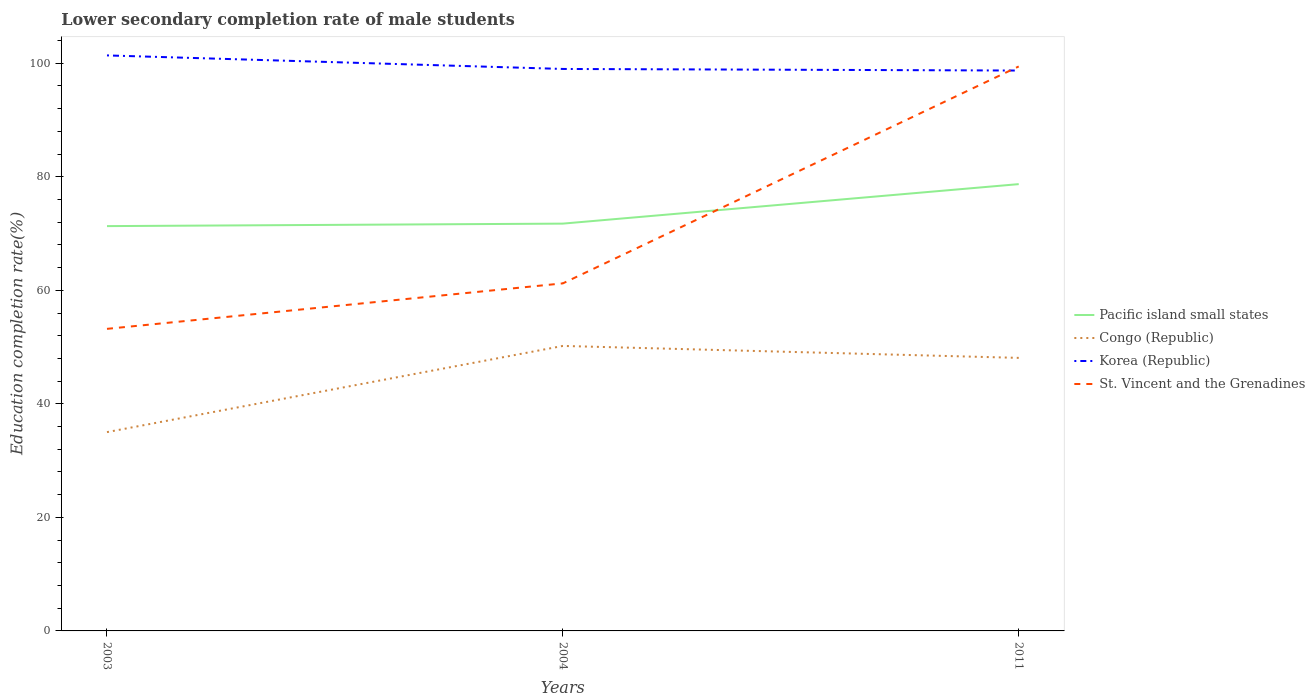How many different coloured lines are there?
Your answer should be very brief. 4. Is the number of lines equal to the number of legend labels?
Your response must be concise. Yes. Across all years, what is the maximum lower secondary completion rate of male students in Korea (Republic)?
Offer a very short reply. 98.72. What is the total lower secondary completion rate of male students in Pacific island small states in the graph?
Your response must be concise. -0.44. What is the difference between the highest and the second highest lower secondary completion rate of male students in Congo (Republic)?
Offer a very short reply. 15.18. Is the lower secondary completion rate of male students in Pacific island small states strictly greater than the lower secondary completion rate of male students in Korea (Republic) over the years?
Give a very brief answer. Yes. How many lines are there?
Offer a terse response. 4. Does the graph contain any zero values?
Keep it short and to the point. No. Does the graph contain grids?
Keep it short and to the point. No. How are the legend labels stacked?
Ensure brevity in your answer.  Vertical. What is the title of the graph?
Give a very brief answer. Lower secondary completion rate of male students. What is the label or title of the X-axis?
Keep it short and to the point. Years. What is the label or title of the Y-axis?
Give a very brief answer. Education completion rate(%). What is the Education completion rate(%) in Pacific island small states in 2003?
Offer a terse response. 71.31. What is the Education completion rate(%) of Congo (Republic) in 2003?
Give a very brief answer. 35.02. What is the Education completion rate(%) of Korea (Republic) in 2003?
Your answer should be compact. 101.38. What is the Education completion rate(%) in St. Vincent and the Grenadines in 2003?
Your answer should be compact. 53.21. What is the Education completion rate(%) in Pacific island small states in 2004?
Your answer should be very brief. 71.75. What is the Education completion rate(%) in Congo (Republic) in 2004?
Make the answer very short. 50.21. What is the Education completion rate(%) in Korea (Republic) in 2004?
Provide a succinct answer. 99. What is the Education completion rate(%) of St. Vincent and the Grenadines in 2004?
Offer a very short reply. 61.23. What is the Education completion rate(%) of Pacific island small states in 2011?
Provide a short and direct response. 78.71. What is the Education completion rate(%) of Congo (Republic) in 2011?
Your answer should be compact. 48.1. What is the Education completion rate(%) of Korea (Republic) in 2011?
Ensure brevity in your answer.  98.72. What is the Education completion rate(%) in St. Vincent and the Grenadines in 2011?
Provide a short and direct response. 99.44. Across all years, what is the maximum Education completion rate(%) of Pacific island small states?
Make the answer very short. 78.71. Across all years, what is the maximum Education completion rate(%) of Congo (Republic)?
Your answer should be very brief. 50.21. Across all years, what is the maximum Education completion rate(%) of Korea (Republic)?
Make the answer very short. 101.38. Across all years, what is the maximum Education completion rate(%) of St. Vincent and the Grenadines?
Provide a succinct answer. 99.44. Across all years, what is the minimum Education completion rate(%) of Pacific island small states?
Ensure brevity in your answer.  71.31. Across all years, what is the minimum Education completion rate(%) in Congo (Republic)?
Your response must be concise. 35.02. Across all years, what is the minimum Education completion rate(%) of Korea (Republic)?
Your answer should be very brief. 98.72. Across all years, what is the minimum Education completion rate(%) in St. Vincent and the Grenadines?
Offer a very short reply. 53.21. What is the total Education completion rate(%) in Pacific island small states in the graph?
Keep it short and to the point. 221.77. What is the total Education completion rate(%) in Congo (Republic) in the graph?
Offer a terse response. 133.33. What is the total Education completion rate(%) of Korea (Republic) in the graph?
Keep it short and to the point. 299.1. What is the total Education completion rate(%) of St. Vincent and the Grenadines in the graph?
Make the answer very short. 213.88. What is the difference between the Education completion rate(%) in Pacific island small states in 2003 and that in 2004?
Your response must be concise. -0.44. What is the difference between the Education completion rate(%) of Congo (Republic) in 2003 and that in 2004?
Keep it short and to the point. -15.18. What is the difference between the Education completion rate(%) of Korea (Republic) in 2003 and that in 2004?
Give a very brief answer. 2.39. What is the difference between the Education completion rate(%) in St. Vincent and the Grenadines in 2003 and that in 2004?
Give a very brief answer. -8.01. What is the difference between the Education completion rate(%) in Pacific island small states in 2003 and that in 2011?
Offer a terse response. -7.4. What is the difference between the Education completion rate(%) in Congo (Republic) in 2003 and that in 2011?
Keep it short and to the point. -13.08. What is the difference between the Education completion rate(%) in Korea (Republic) in 2003 and that in 2011?
Ensure brevity in your answer.  2.67. What is the difference between the Education completion rate(%) in St. Vincent and the Grenadines in 2003 and that in 2011?
Keep it short and to the point. -46.22. What is the difference between the Education completion rate(%) of Pacific island small states in 2004 and that in 2011?
Your answer should be very brief. -6.96. What is the difference between the Education completion rate(%) of Congo (Republic) in 2004 and that in 2011?
Keep it short and to the point. 2.11. What is the difference between the Education completion rate(%) of Korea (Republic) in 2004 and that in 2011?
Offer a very short reply. 0.28. What is the difference between the Education completion rate(%) of St. Vincent and the Grenadines in 2004 and that in 2011?
Provide a succinct answer. -38.21. What is the difference between the Education completion rate(%) in Pacific island small states in 2003 and the Education completion rate(%) in Congo (Republic) in 2004?
Your answer should be very brief. 21.11. What is the difference between the Education completion rate(%) in Pacific island small states in 2003 and the Education completion rate(%) in Korea (Republic) in 2004?
Your answer should be compact. -27.69. What is the difference between the Education completion rate(%) of Pacific island small states in 2003 and the Education completion rate(%) of St. Vincent and the Grenadines in 2004?
Provide a succinct answer. 10.09. What is the difference between the Education completion rate(%) in Congo (Republic) in 2003 and the Education completion rate(%) in Korea (Republic) in 2004?
Your response must be concise. -63.98. What is the difference between the Education completion rate(%) in Congo (Republic) in 2003 and the Education completion rate(%) in St. Vincent and the Grenadines in 2004?
Offer a terse response. -26.2. What is the difference between the Education completion rate(%) in Korea (Republic) in 2003 and the Education completion rate(%) in St. Vincent and the Grenadines in 2004?
Provide a short and direct response. 40.16. What is the difference between the Education completion rate(%) of Pacific island small states in 2003 and the Education completion rate(%) of Congo (Republic) in 2011?
Make the answer very short. 23.21. What is the difference between the Education completion rate(%) of Pacific island small states in 2003 and the Education completion rate(%) of Korea (Republic) in 2011?
Offer a terse response. -27.41. What is the difference between the Education completion rate(%) of Pacific island small states in 2003 and the Education completion rate(%) of St. Vincent and the Grenadines in 2011?
Make the answer very short. -28.13. What is the difference between the Education completion rate(%) in Congo (Republic) in 2003 and the Education completion rate(%) in Korea (Republic) in 2011?
Provide a succinct answer. -63.7. What is the difference between the Education completion rate(%) in Congo (Republic) in 2003 and the Education completion rate(%) in St. Vincent and the Grenadines in 2011?
Give a very brief answer. -64.42. What is the difference between the Education completion rate(%) of Korea (Republic) in 2003 and the Education completion rate(%) of St. Vincent and the Grenadines in 2011?
Your answer should be compact. 1.95. What is the difference between the Education completion rate(%) of Pacific island small states in 2004 and the Education completion rate(%) of Congo (Republic) in 2011?
Your answer should be very brief. 23.65. What is the difference between the Education completion rate(%) in Pacific island small states in 2004 and the Education completion rate(%) in Korea (Republic) in 2011?
Ensure brevity in your answer.  -26.97. What is the difference between the Education completion rate(%) of Pacific island small states in 2004 and the Education completion rate(%) of St. Vincent and the Grenadines in 2011?
Offer a terse response. -27.69. What is the difference between the Education completion rate(%) of Congo (Republic) in 2004 and the Education completion rate(%) of Korea (Republic) in 2011?
Give a very brief answer. -48.51. What is the difference between the Education completion rate(%) in Congo (Republic) in 2004 and the Education completion rate(%) in St. Vincent and the Grenadines in 2011?
Provide a short and direct response. -49.23. What is the difference between the Education completion rate(%) in Korea (Republic) in 2004 and the Education completion rate(%) in St. Vincent and the Grenadines in 2011?
Your answer should be very brief. -0.44. What is the average Education completion rate(%) of Pacific island small states per year?
Your answer should be compact. 73.92. What is the average Education completion rate(%) of Congo (Republic) per year?
Provide a short and direct response. 44.44. What is the average Education completion rate(%) of Korea (Republic) per year?
Give a very brief answer. 99.7. What is the average Education completion rate(%) in St. Vincent and the Grenadines per year?
Provide a succinct answer. 71.29. In the year 2003, what is the difference between the Education completion rate(%) in Pacific island small states and Education completion rate(%) in Congo (Republic)?
Provide a short and direct response. 36.29. In the year 2003, what is the difference between the Education completion rate(%) in Pacific island small states and Education completion rate(%) in Korea (Republic)?
Make the answer very short. -30.07. In the year 2003, what is the difference between the Education completion rate(%) of Pacific island small states and Education completion rate(%) of St. Vincent and the Grenadines?
Your response must be concise. 18.1. In the year 2003, what is the difference between the Education completion rate(%) of Congo (Republic) and Education completion rate(%) of Korea (Republic)?
Keep it short and to the point. -66.36. In the year 2003, what is the difference between the Education completion rate(%) of Congo (Republic) and Education completion rate(%) of St. Vincent and the Grenadines?
Your answer should be very brief. -18.19. In the year 2003, what is the difference between the Education completion rate(%) of Korea (Republic) and Education completion rate(%) of St. Vincent and the Grenadines?
Ensure brevity in your answer.  48.17. In the year 2004, what is the difference between the Education completion rate(%) in Pacific island small states and Education completion rate(%) in Congo (Republic)?
Offer a very short reply. 21.55. In the year 2004, what is the difference between the Education completion rate(%) in Pacific island small states and Education completion rate(%) in Korea (Republic)?
Your answer should be compact. -27.25. In the year 2004, what is the difference between the Education completion rate(%) in Pacific island small states and Education completion rate(%) in St. Vincent and the Grenadines?
Offer a terse response. 10.53. In the year 2004, what is the difference between the Education completion rate(%) of Congo (Republic) and Education completion rate(%) of Korea (Republic)?
Offer a very short reply. -48.79. In the year 2004, what is the difference between the Education completion rate(%) in Congo (Republic) and Education completion rate(%) in St. Vincent and the Grenadines?
Provide a succinct answer. -11.02. In the year 2004, what is the difference between the Education completion rate(%) in Korea (Republic) and Education completion rate(%) in St. Vincent and the Grenadines?
Offer a terse response. 37.77. In the year 2011, what is the difference between the Education completion rate(%) of Pacific island small states and Education completion rate(%) of Congo (Republic)?
Provide a succinct answer. 30.61. In the year 2011, what is the difference between the Education completion rate(%) in Pacific island small states and Education completion rate(%) in Korea (Republic)?
Keep it short and to the point. -20.01. In the year 2011, what is the difference between the Education completion rate(%) in Pacific island small states and Education completion rate(%) in St. Vincent and the Grenadines?
Your answer should be very brief. -20.73. In the year 2011, what is the difference between the Education completion rate(%) of Congo (Republic) and Education completion rate(%) of Korea (Republic)?
Offer a terse response. -50.62. In the year 2011, what is the difference between the Education completion rate(%) of Congo (Republic) and Education completion rate(%) of St. Vincent and the Grenadines?
Make the answer very short. -51.34. In the year 2011, what is the difference between the Education completion rate(%) of Korea (Republic) and Education completion rate(%) of St. Vincent and the Grenadines?
Provide a short and direct response. -0.72. What is the ratio of the Education completion rate(%) in Congo (Republic) in 2003 to that in 2004?
Provide a succinct answer. 0.7. What is the ratio of the Education completion rate(%) of Korea (Republic) in 2003 to that in 2004?
Provide a short and direct response. 1.02. What is the ratio of the Education completion rate(%) of St. Vincent and the Grenadines in 2003 to that in 2004?
Offer a very short reply. 0.87. What is the ratio of the Education completion rate(%) of Pacific island small states in 2003 to that in 2011?
Your response must be concise. 0.91. What is the ratio of the Education completion rate(%) in Congo (Republic) in 2003 to that in 2011?
Ensure brevity in your answer.  0.73. What is the ratio of the Education completion rate(%) in St. Vincent and the Grenadines in 2003 to that in 2011?
Your answer should be very brief. 0.54. What is the ratio of the Education completion rate(%) of Pacific island small states in 2004 to that in 2011?
Make the answer very short. 0.91. What is the ratio of the Education completion rate(%) in Congo (Republic) in 2004 to that in 2011?
Ensure brevity in your answer.  1.04. What is the ratio of the Education completion rate(%) in Korea (Republic) in 2004 to that in 2011?
Offer a terse response. 1. What is the ratio of the Education completion rate(%) of St. Vincent and the Grenadines in 2004 to that in 2011?
Ensure brevity in your answer.  0.62. What is the difference between the highest and the second highest Education completion rate(%) in Pacific island small states?
Make the answer very short. 6.96. What is the difference between the highest and the second highest Education completion rate(%) in Congo (Republic)?
Make the answer very short. 2.11. What is the difference between the highest and the second highest Education completion rate(%) in Korea (Republic)?
Your answer should be compact. 2.39. What is the difference between the highest and the second highest Education completion rate(%) in St. Vincent and the Grenadines?
Provide a short and direct response. 38.21. What is the difference between the highest and the lowest Education completion rate(%) of Pacific island small states?
Keep it short and to the point. 7.4. What is the difference between the highest and the lowest Education completion rate(%) of Congo (Republic)?
Give a very brief answer. 15.18. What is the difference between the highest and the lowest Education completion rate(%) in Korea (Republic)?
Provide a succinct answer. 2.67. What is the difference between the highest and the lowest Education completion rate(%) of St. Vincent and the Grenadines?
Your answer should be compact. 46.22. 